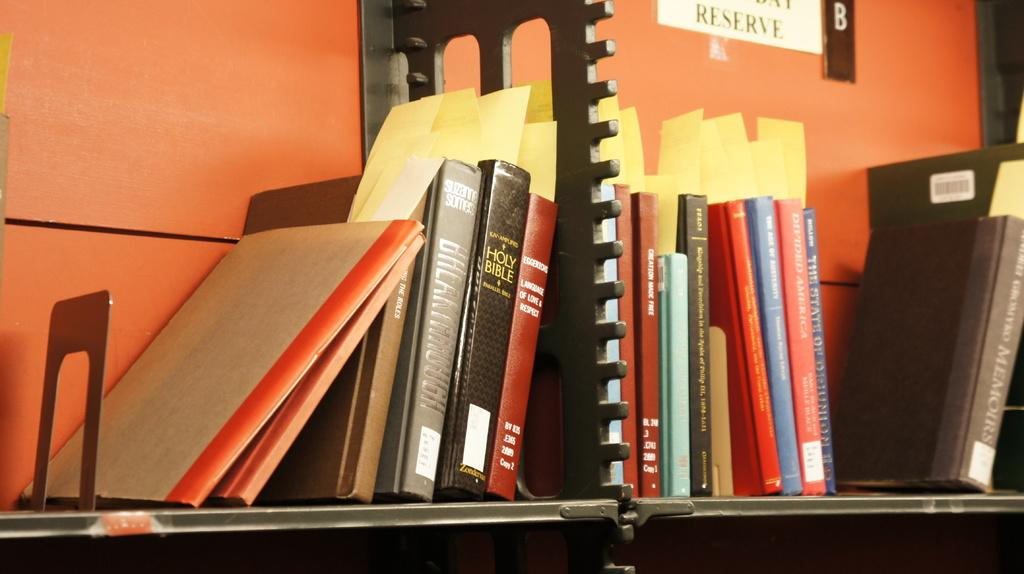Provide a one-sentence caption for the provided image. A stack of books on a cart including a KJV Holy Bible. 